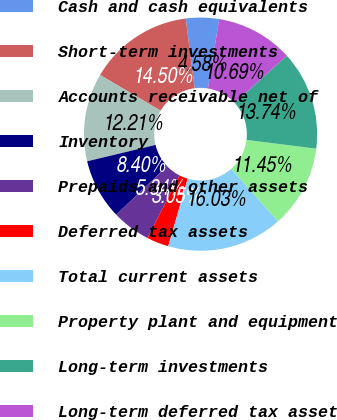Convert chart. <chart><loc_0><loc_0><loc_500><loc_500><pie_chart><fcel>Cash and cash equivalents<fcel>Short-term investments<fcel>Accounts receivable net of<fcel>Inventory<fcel>Prepaids and other assets<fcel>Deferred tax assets<fcel>Total current assets<fcel>Property plant and equipment<fcel>Long-term investments<fcel>Long-term deferred tax asset<nl><fcel>4.58%<fcel>14.5%<fcel>12.21%<fcel>8.4%<fcel>5.34%<fcel>3.05%<fcel>16.03%<fcel>11.45%<fcel>13.74%<fcel>10.69%<nl></chart> 